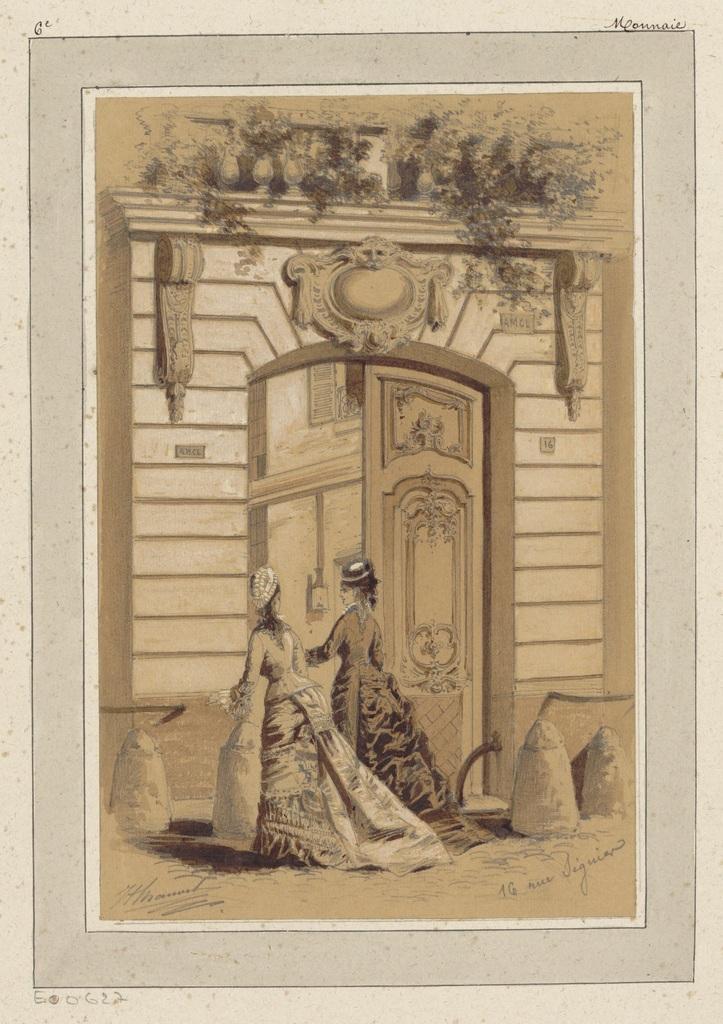Could you give a brief overview of what you see in this image? This image consists of a painting of a building. In front of this building there are two women walking. At the bottom of this painting there is some text. 